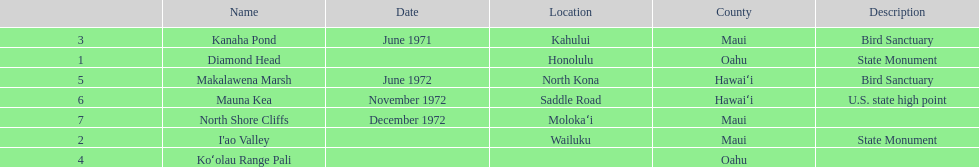How many dates are in 1972? 3. 